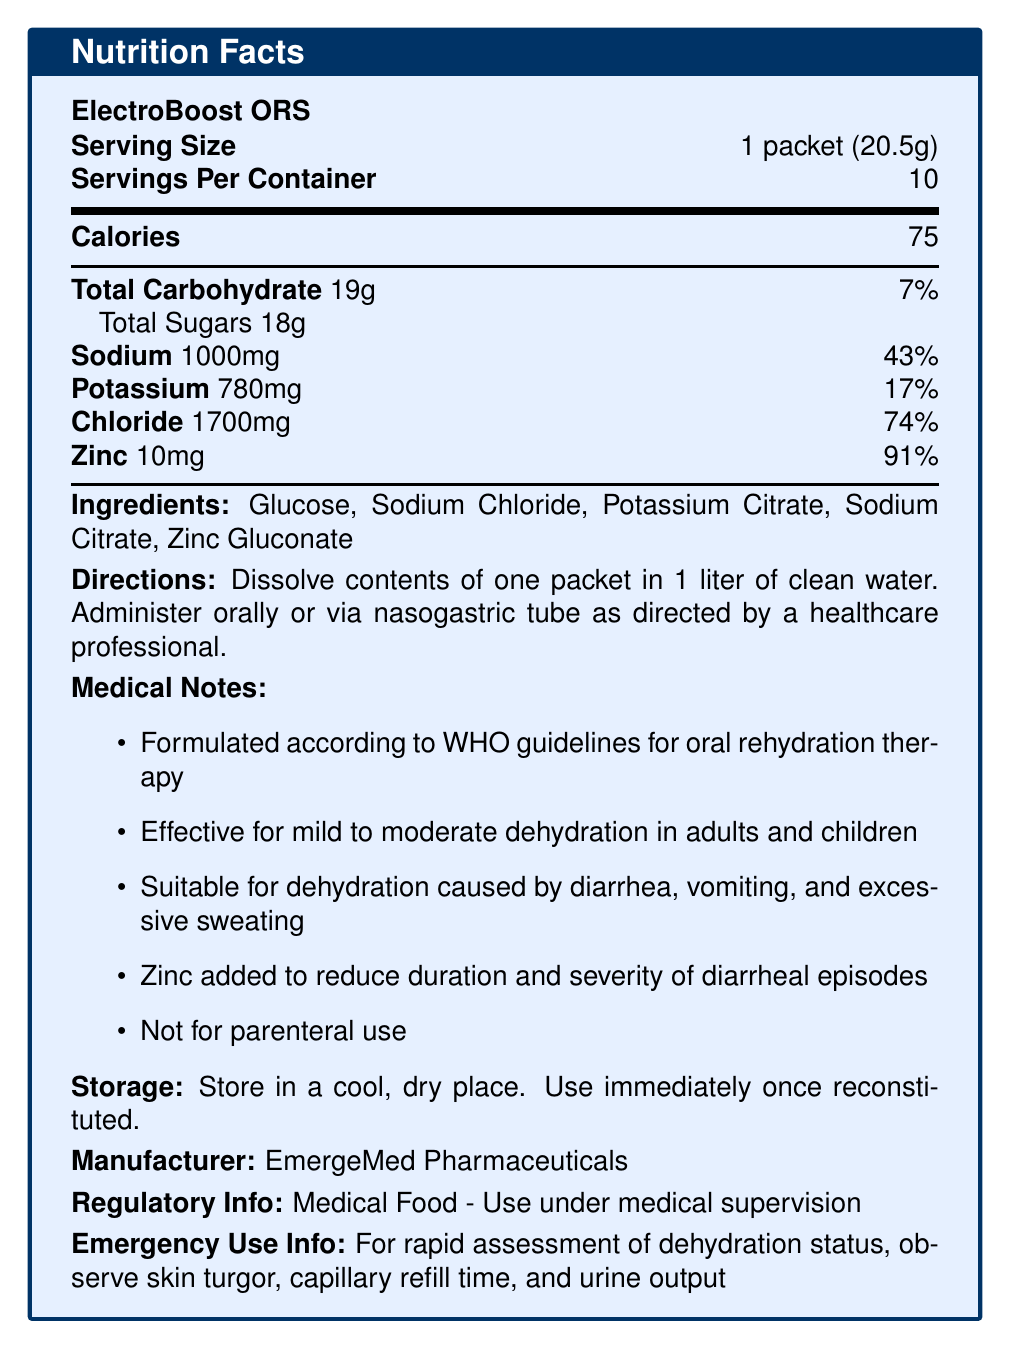What is the calorie count per serving of ElectroBoost ORS? The document lists the calorie count as 75 in the "Nutrition Facts" section.
Answer: 75 calories How many servings are in one container of ElectroBoost ORS? The document specifies that there are 10 servings per container in the "Serving Size and Servings Per Container" section.
Answer: 10 servings What is the amount of sodium per serving? The document lists 1000mg of sodium per serving in the "Nutrition Facts" section.
Answer: 1000mg What ingredient is primarily responsible for the glucose content in ElectroBoost ORS? The ingredient list includes Glucose, which is the primary source of glucose.
Answer: Glucose Is the rehydration solution suitable for parenteral use? The document explicitly mentions "Not for parenteral use" under "Medical Notes."
Answer: No What percentage of the daily value of chloride does one serving deliver? A. 17% B. 43% C. 74% D. 91% The document lists the amount of chloride as 1700mg, which corresponds to 74% of the daily value.
Answer: C. 74% Which organization’s guidelines does the ElectroBoost ORS formulation follow? A. FDA B. WHO C. CDC D. NIH The document states "Formulated according to WHO guidelines for oral rehydration therapy" under "Medical Notes."
Answer: B. WHO Does the product contain potassium citrate? The ingredient list includes Potassium Citrate.
Answer: Yes Can this product be consumed by children experiencing mild dehydration? The document specifies that it is "Effective for mild to moderate dehydration in adults and children" under "Medical Notes."
Answer: Yes What is the recommended use for the product once reconstituted? The document states "Use immediately once reconstituted" under "Storage Instructions."
Answer: Use immediately Summary: Describe the main purpose of ElectroBoost ORS. The document provides detailed information about ElectroBoost ORS, including its serving size, nutritional content, intended use, ingredients, and storage instructions. It is designed as an oral rehydration solution effective for treating dehydration and must be used immediately once reconstituted.
Answer: ElectroBoost ORS is a specialized oral rehydration solution formulated according to WHO guidelines to treat mild to moderate dehydration. It contains electrolytes and glucose to replenish lost fluids and is suitable for both adults and children suffering from dehydration due to diarrhea, vomiting, and excessive sweating. Additionally, it includes zinc to reduce the duration and severity of diarrheal episodes. The solution should be used under medical supervision and is not for parenteral use. What is the pH level of ElectroBoost ORS solution? The document provides no information about the pH level of the ElectroBoost ORS solution.
Answer: Cannot be determined 